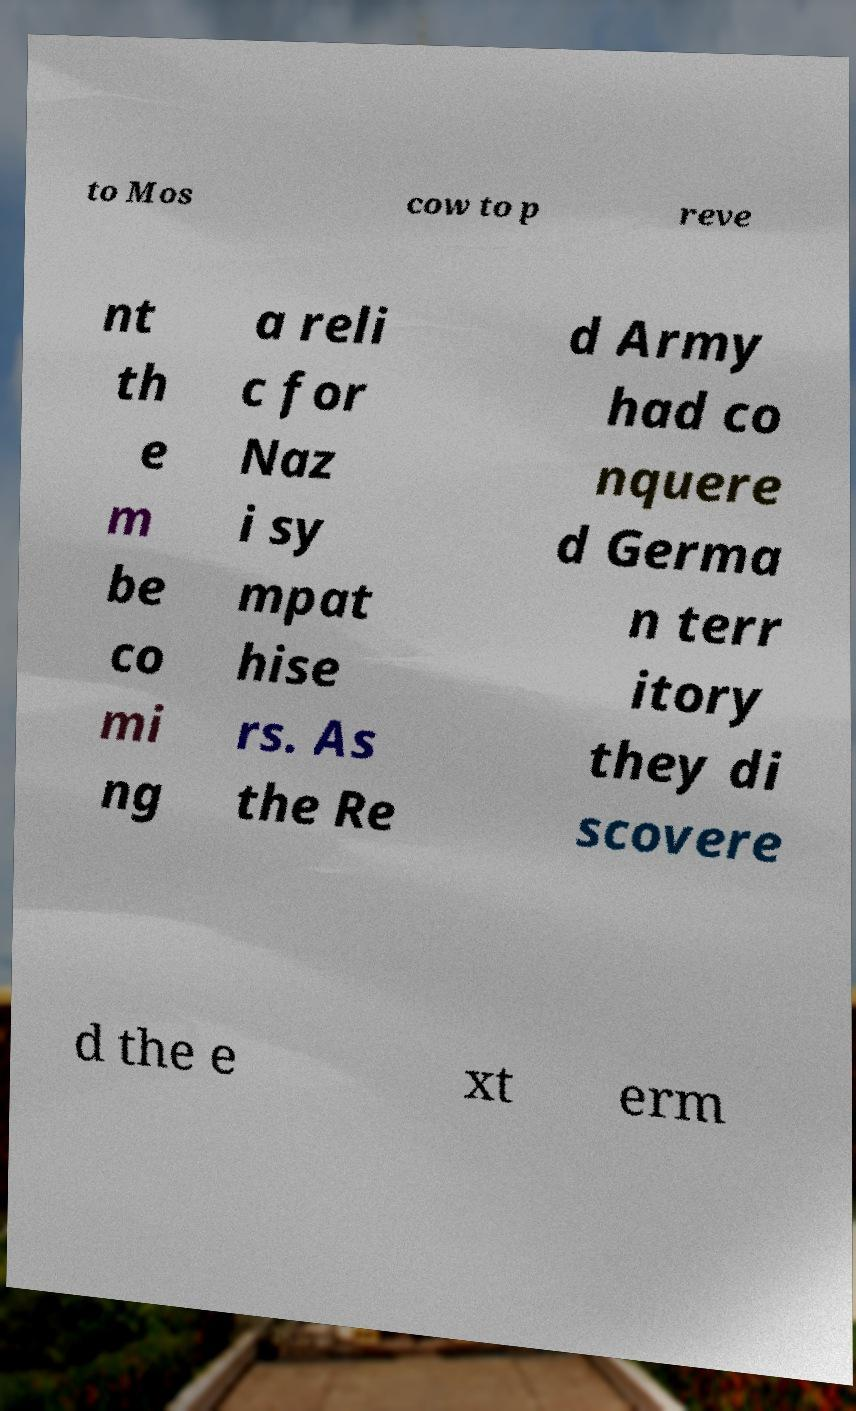For documentation purposes, I need the text within this image transcribed. Could you provide that? to Mos cow to p reve nt th e m be co mi ng a reli c for Naz i sy mpat hise rs. As the Re d Army had co nquere d Germa n terr itory they di scovere d the e xt erm 